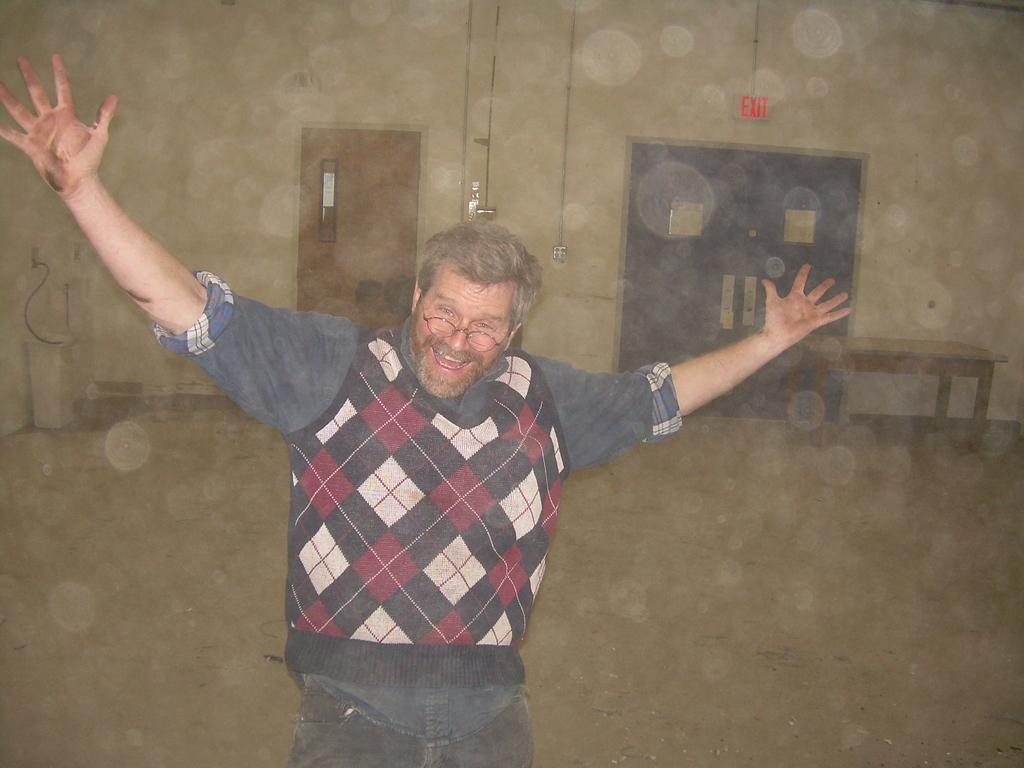Please provide a concise description of this image. This is the picture taken in a room, the man in sweater was standing on floor and man is having spectacle. Behinds the man there are wooden and other black door and wall on the wall there is exit sign board and switch board and on the floor there is a table and some machine. 